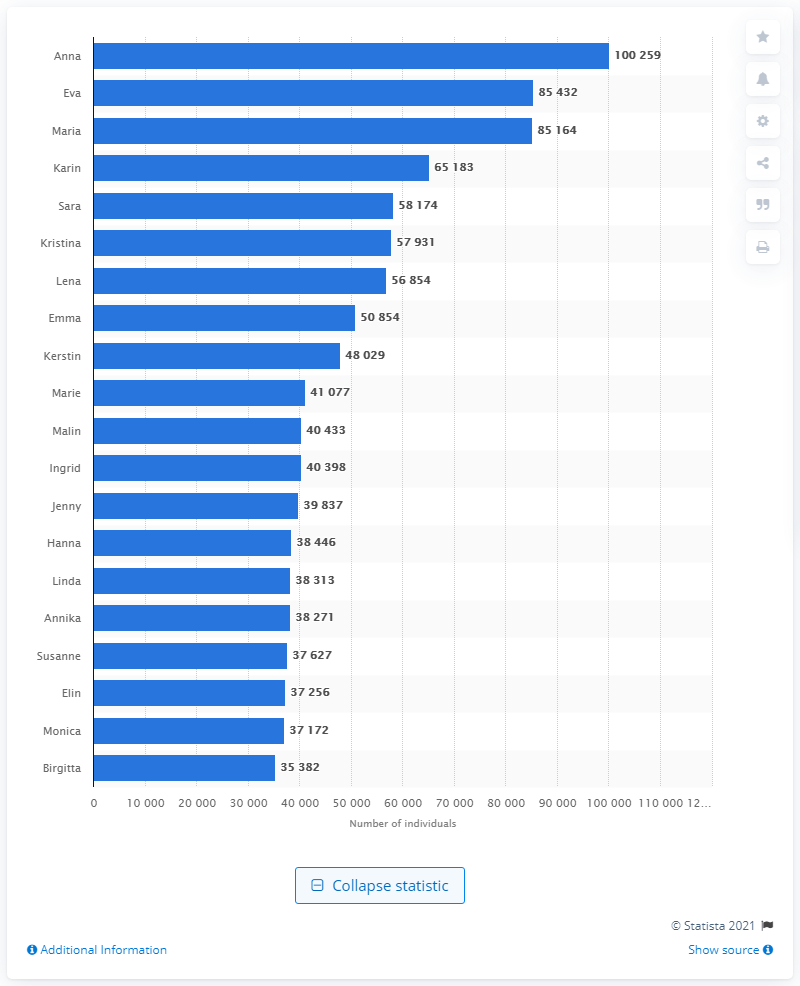Indicate a few pertinent items in this graphic. According to information from Sweden, the most popular female name is Eva. According to data, the most common female name in Sweden is Anna. 